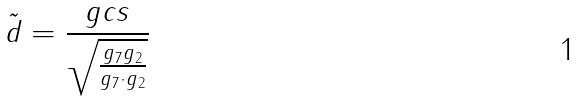Convert formula to latex. <formula><loc_0><loc_0><loc_500><loc_500>\tilde { d } = \frac { g c s } { \sqrt { \frac { g _ { 7 } g _ { 2 } } { g _ { 7 } \cdot g _ { 2 } } } }</formula> 